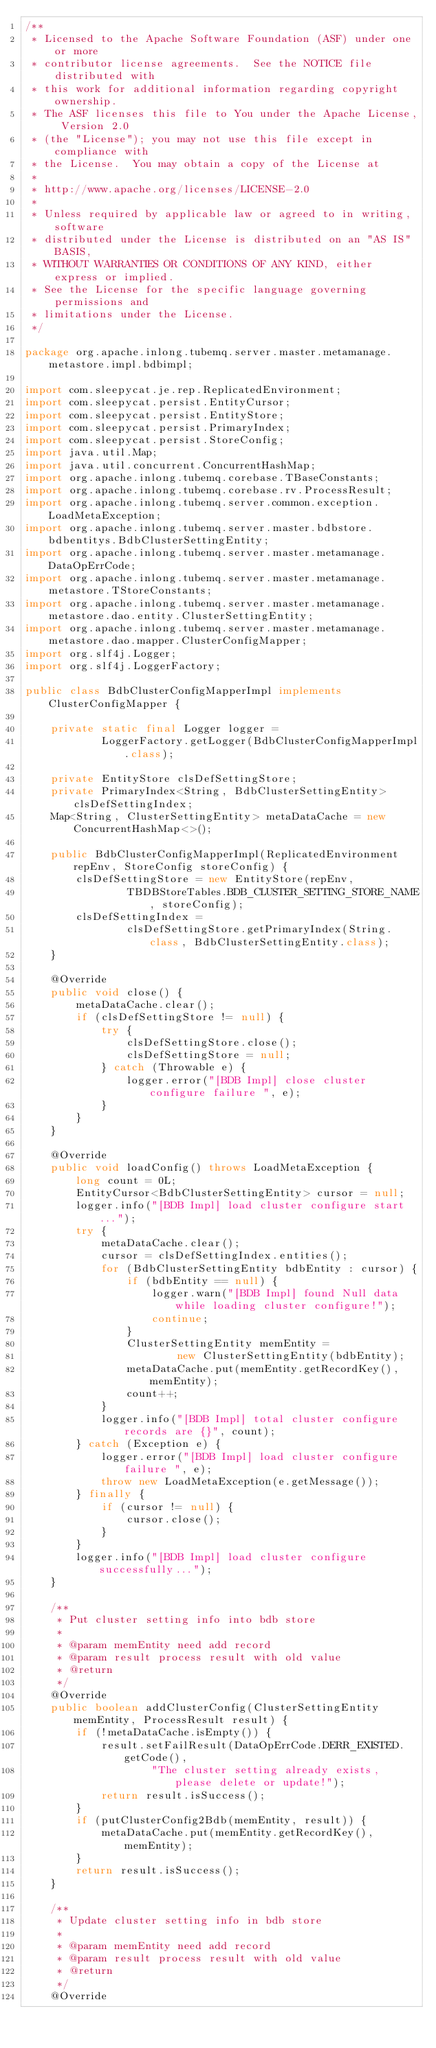<code> <loc_0><loc_0><loc_500><loc_500><_Java_>/**
 * Licensed to the Apache Software Foundation (ASF) under one or more
 * contributor license agreements.  See the NOTICE file distributed with
 * this work for additional information regarding copyright ownership.
 * The ASF licenses this file to You under the Apache License, Version 2.0
 * (the "License"); you may not use this file except in compliance with
 * the License.  You may obtain a copy of the License at
 *
 * http://www.apache.org/licenses/LICENSE-2.0
 *
 * Unless required by applicable law or agreed to in writing, software
 * distributed under the License is distributed on an "AS IS" BASIS,
 * WITHOUT WARRANTIES OR CONDITIONS OF ANY KIND, either express or implied.
 * See the License for the specific language governing permissions and
 * limitations under the License.
 */

package org.apache.inlong.tubemq.server.master.metamanage.metastore.impl.bdbimpl;

import com.sleepycat.je.rep.ReplicatedEnvironment;
import com.sleepycat.persist.EntityCursor;
import com.sleepycat.persist.EntityStore;
import com.sleepycat.persist.PrimaryIndex;
import com.sleepycat.persist.StoreConfig;
import java.util.Map;
import java.util.concurrent.ConcurrentHashMap;
import org.apache.inlong.tubemq.corebase.TBaseConstants;
import org.apache.inlong.tubemq.corebase.rv.ProcessResult;
import org.apache.inlong.tubemq.server.common.exception.LoadMetaException;
import org.apache.inlong.tubemq.server.master.bdbstore.bdbentitys.BdbClusterSettingEntity;
import org.apache.inlong.tubemq.server.master.metamanage.DataOpErrCode;
import org.apache.inlong.tubemq.server.master.metamanage.metastore.TStoreConstants;
import org.apache.inlong.tubemq.server.master.metamanage.metastore.dao.entity.ClusterSettingEntity;
import org.apache.inlong.tubemq.server.master.metamanage.metastore.dao.mapper.ClusterConfigMapper;
import org.slf4j.Logger;
import org.slf4j.LoggerFactory;

public class BdbClusterConfigMapperImpl implements ClusterConfigMapper {

    private static final Logger logger =
            LoggerFactory.getLogger(BdbClusterConfigMapperImpl.class);

    private EntityStore clsDefSettingStore;
    private PrimaryIndex<String, BdbClusterSettingEntity> clsDefSettingIndex;
    Map<String, ClusterSettingEntity> metaDataCache = new ConcurrentHashMap<>();

    public BdbClusterConfigMapperImpl(ReplicatedEnvironment repEnv, StoreConfig storeConfig) {
        clsDefSettingStore = new EntityStore(repEnv,
                TBDBStoreTables.BDB_CLUSTER_SETTING_STORE_NAME, storeConfig);
        clsDefSettingIndex =
                clsDefSettingStore.getPrimaryIndex(String.class, BdbClusterSettingEntity.class);
    }

    @Override
    public void close() {
        metaDataCache.clear();
        if (clsDefSettingStore != null) {
            try {
                clsDefSettingStore.close();
                clsDefSettingStore = null;
            } catch (Throwable e) {
                logger.error("[BDB Impl] close cluster configure failure ", e);
            }
        }
    }

    @Override
    public void loadConfig() throws LoadMetaException {
        long count = 0L;
        EntityCursor<BdbClusterSettingEntity> cursor = null;
        logger.info("[BDB Impl] load cluster configure start...");
        try {
            metaDataCache.clear();
            cursor = clsDefSettingIndex.entities();
            for (BdbClusterSettingEntity bdbEntity : cursor) {
                if (bdbEntity == null) {
                    logger.warn("[BDB Impl] found Null data while loading cluster configure!");
                    continue;
                }
                ClusterSettingEntity memEntity =
                        new ClusterSettingEntity(bdbEntity);
                metaDataCache.put(memEntity.getRecordKey(), memEntity);
                count++;
            }
            logger.info("[BDB Impl] total cluster configure records are {}", count);
        } catch (Exception e) {
            logger.error("[BDB Impl] load cluster configure failure ", e);
            throw new LoadMetaException(e.getMessage());
        } finally {
            if (cursor != null) {
                cursor.close();
            }
        }
        logger.info("[BDB Impl] load cluster configure successfully...");
    }

    /**
     * Put cluster setting info into bdb store
     *
     * @param memEntity need add record
     * @param result process result with old value
     * @return
     */
    @Override
    public boolean addClusterConfig(ClusterSettingEntity memEntity, ProcessResult result) {
        if (!metaDataCache.isEmpty()) {
            result.setFailResult(DataOpErrCode.DERR_EXISTED.getCode(),
                    "The cluster setting already exists, please delete or update!");
            return result.isSuccess();
        }
        if (putClusterConfig2Bdb(memEntity, result)) {
            metaDataCache.put(memEntity.getRecordKey(), memEntity);
        }
        return result.isSuccess();
    }

    /**
     * Update cluster setting info in bdb store
     *
     * @param memEntity need add record
     * @param result process result with old value
     * @return
     */
    @Override</code> 